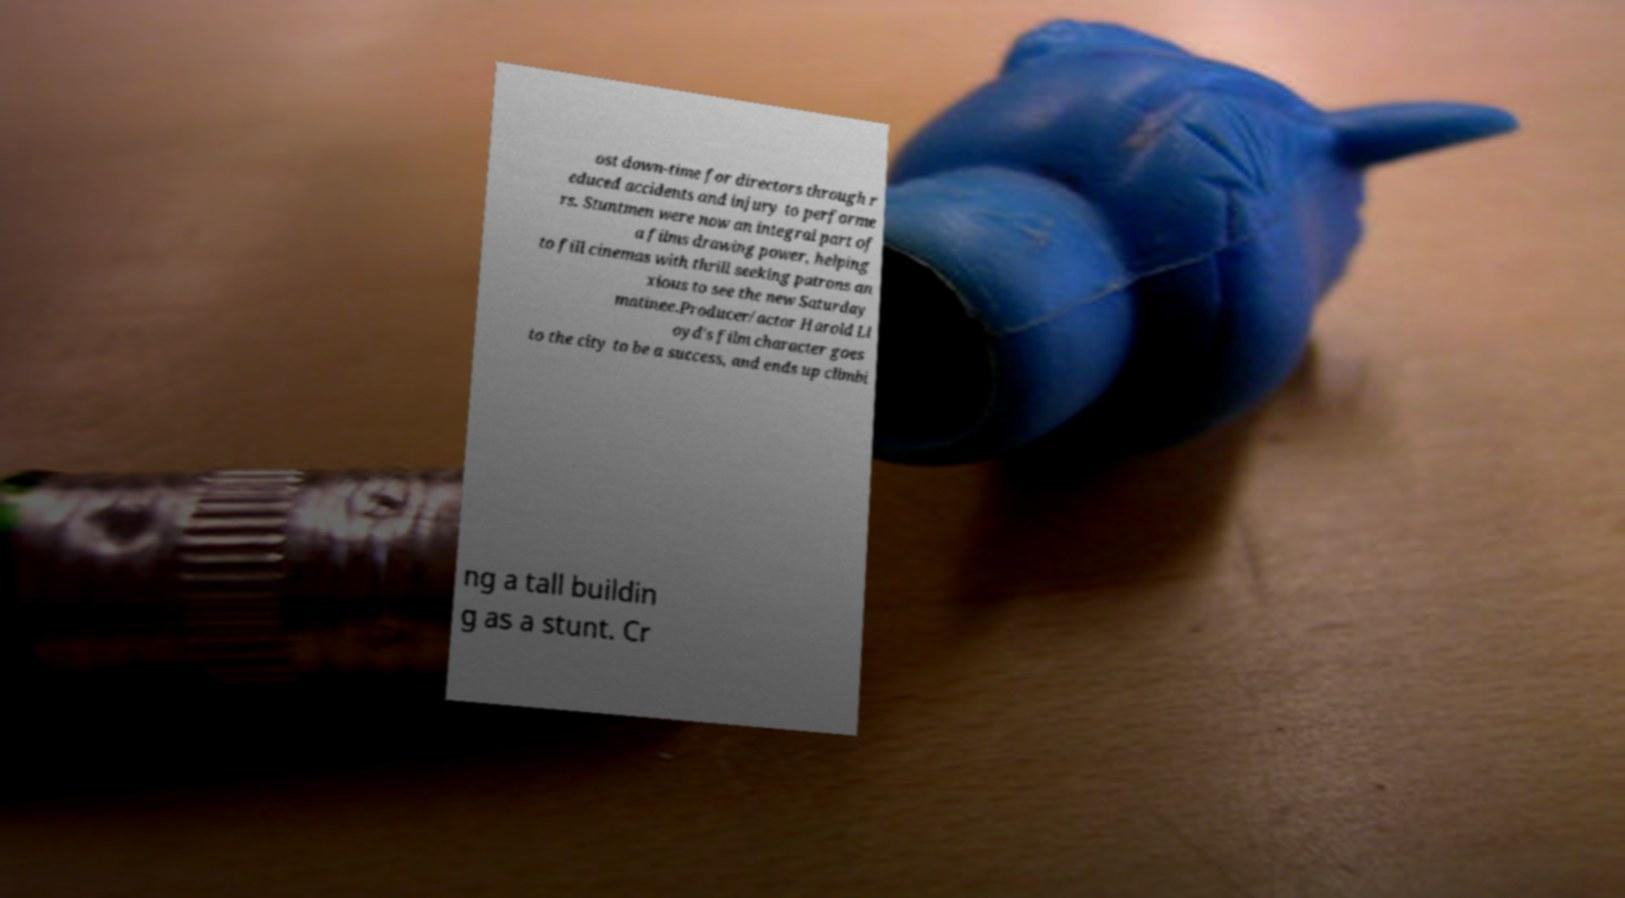Can you accurately transcribe the text from the provided image for me? ost down-time for directors through r educed accidents and injury to performe rs. Stuntmen were now an integral part of a films drawing power, helping to fill cinemas with thrill seeking patrons an xious to see the new Saturday matinee.Producer/actor Harold Ll oyd's film character goes to the city to be a success, and ends up climbi ng a tall buildin g as a stunt. Cr 